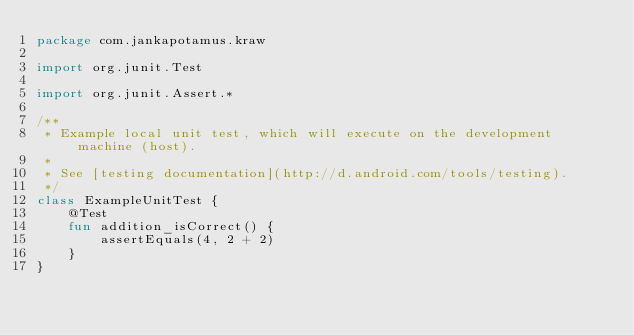<code> <loc_0><loc_0><loc_500><loc_500><_Kotlin_>package com.jankapotamus.kraw

import org.junit.Test

import org.junit.Assert.*

/**
 * Example local unit test, which will execute on the development machine (host).
 *
 * See [testing documentation](http://d.android.com/tools/testing).
 */
class ExampleUnitTest {
    @Test
    fun addition_isCorrect() {
        assertEquals(4, 2 + 2)
    }
}
</code> 